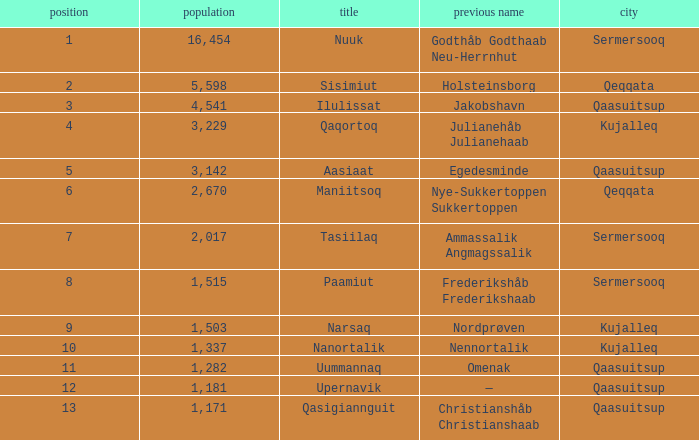Who has a former name of nordprøven? Narsaq. 